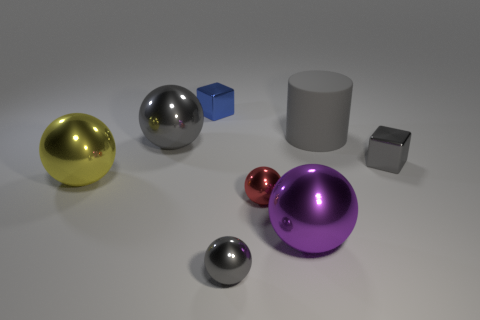What number of cubes are small things or big gray matte objects?
Make the answer very short. 2. Are there fewer metal blocks in front of the large purple ball than yellow cylinders?
Your response must be concise. No. How many other things are made of the same material as the blue object?
Ensure brevity in your answer.  6. Does the yellow metal thing have the same size as the red metallic thing?
Provide a short and direct response. No. How many things are tiny metallic blocks right of the small blue shiny object or small red metal objects?
Your response must be concise. 2. What material is the large object to the left of the gray metal ball on the left side of the blue object?
Give a very brief answer. Metal. Are there any other objects that have the same shape as the matte thing?
Offer a very short reply. No. There is a gray cylinder; is it the same size as the purple metallic object to the right of the tiny blue metal thing?
Provide a short and direct response. Yes. What number of things are gray metallic balls that are behind the large yellow sphere or things right of the yellow metal sphere?
Your response must be concise. 7. Are there more balls that are behind the large purple ball than purple metal balls?
Keep it short and to the point. Yes. 